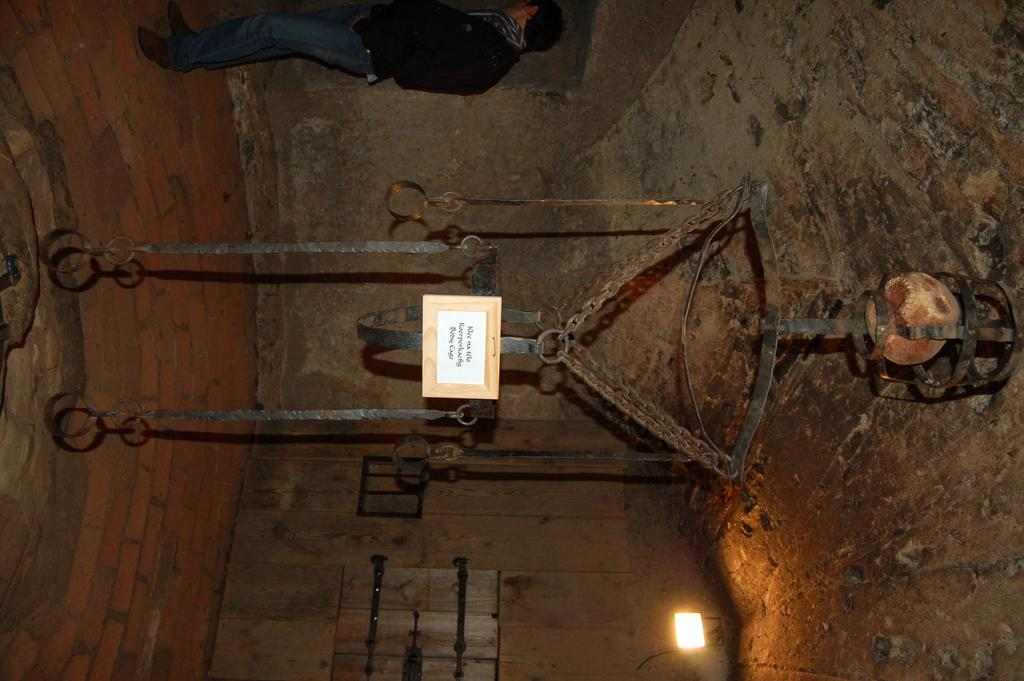What is present in the image? There is a person, rods and chains hanging from the roof, a door, a light, skulls, and a board with text written on it in the image. Can you describe the person in the image? The facts provided do not give a detailed description of the person, but we know that there is a person present in the image. What is the purpose of the rods and chains hanging from the roof? The purpose of the rods and chains hanging from the roof is not specified in the facts provided. Where is the door located in the image? The door is located in the image, but the facts do not specify its exact location. What type of light is present in the image? The facts provided do not specify the type of light present in the image. What does the text on the board say? The facts provided do not give the exact text written on the board. How many cakes are being held by the person in the image? There is no mention of cakes in the image, so we cannot determine if any cakes are being held by the person. 